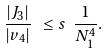<formula> <loc_0><loc_0><loc_500><loc_500>\frac { | J _ { 3 } | } { | v _ { 4 } | } \ \leq s \ \frac { 1 } { N _ { 1 } ^ { 4 } } .</formula> 